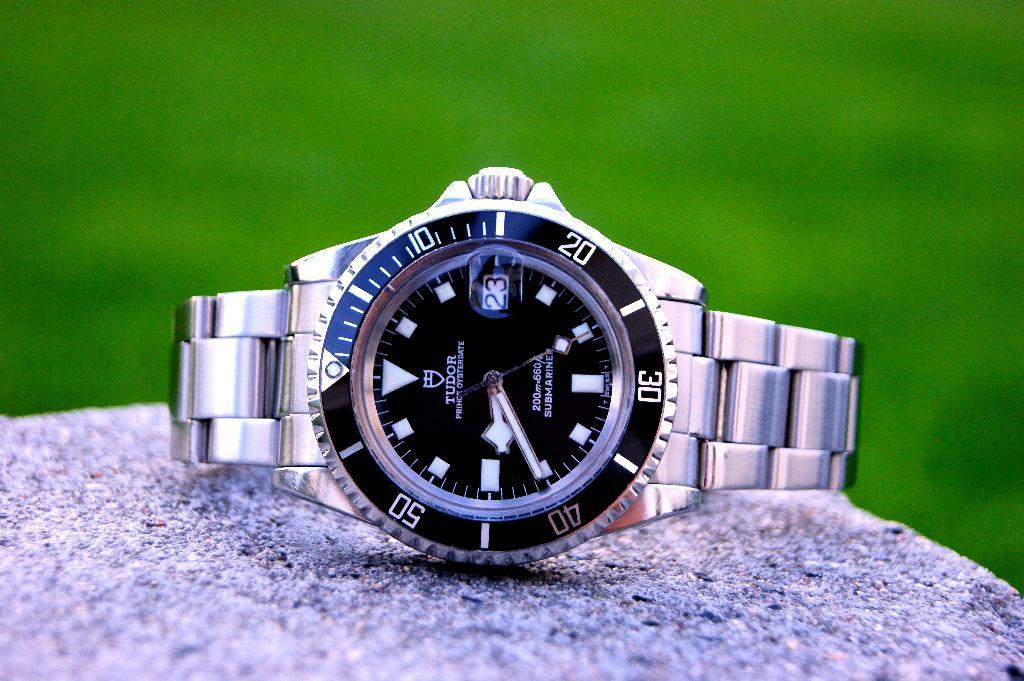<image>
Describe the image concisely. SIlver and black wristwatch which says TUDOR on it. 